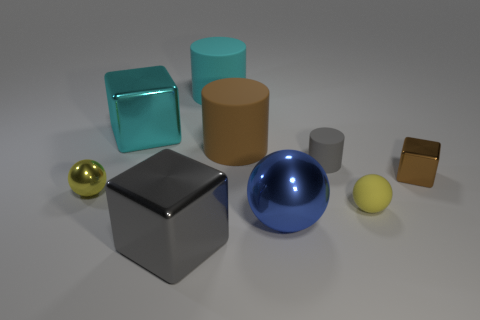Is there anything else that has the same shape as the small gray object?
Your answer should be very brief. Yes. Is the material of the big cyan cylinder the same as the small ball on the right side of the gray cylinder?
Offer a terse response. Yes. What is the color of the ball to the right of the blue shiny thing that is to the right of the large shiny block in front of the yellow rubber ball?
Make the answer very short. Yellow. What is the shape of the matte thing that is the same size as the brown cylinder?
Give a very brief answer. Cylinder. Is there anything else that has the same size as the blue object?
Keep it short and to the point. Yes. There is a cube behind the small rubber cylinder; does it have the same size as the blue metal thing right of the yellow shiny object?
Your answer should be very brief. Yes. What is the size of the brown thing behind the tiny gray rubber cylinder?
Provide a succinct answer. Large. There is a object that is the same color as the tiny cylinder; what is its material?
Offer a very short reply. Metal. The ball that is the same size as the cyan metal thing is what color?
Ensure brevity in your answer.  Blue. Do the cyan cube and the gray cylinder have the same size?
Offer a very short reply. No. 